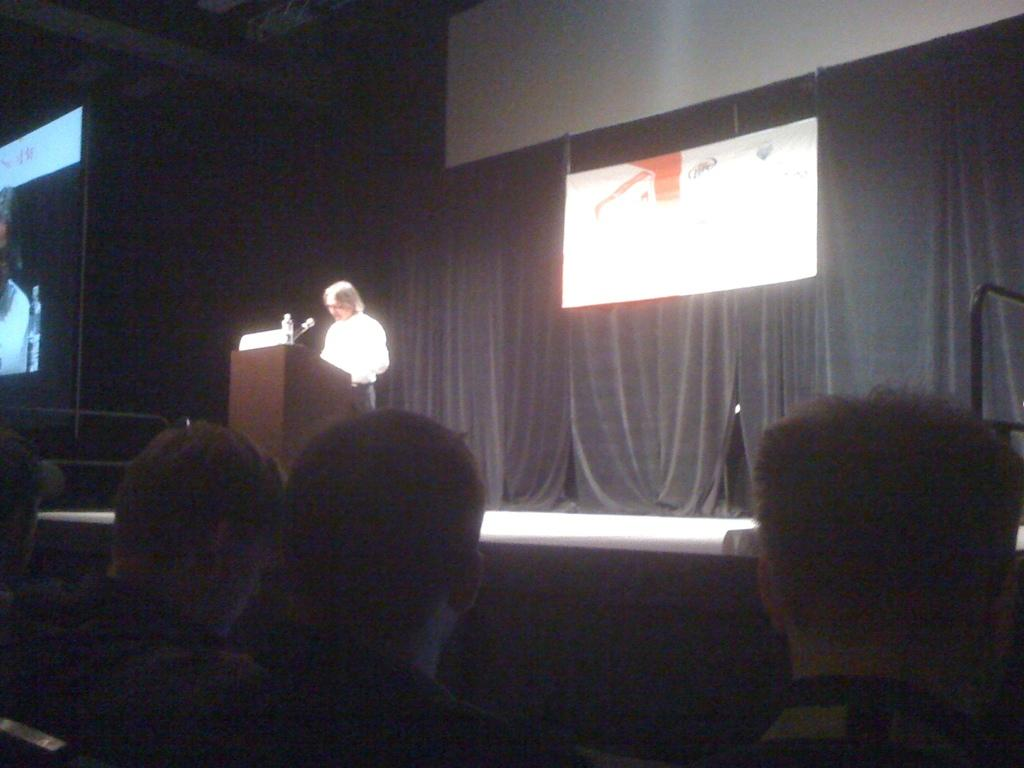How many people are present in the image? There are people in the image, but the exact number cannot be determined from the provided facts. What is the purpose of the screen in the image? The purpose of the screen in the image cannot be determined from the provided facts. What is written or depicted on the banner in the image? The content of the banner in the image cannot be determined from the provided facts. What color or material are the curtains in the image? The color or material of the curtains in the image cannot be determined from the provided facts. What type of bottles are visible in the image? The type of bottles in the image cannot be determined from the provided facts. What is the microphone (mic) used for in the image? The purpose of the microphone (mic) in the image cannot be determined from the provided facts. How many cans of comfort are visible in the image? There is no mention of cans or comfort in the provided facts, so it cannot be determined if they are present in the image. 